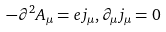<formula> <loc_0><loc_0><loc_500><loc_500>- \partial ^ { 2 } A _ { \mu } = e j _ { \mu } , \partial _ { \mu } j _ { \mu } = 0</formula> 